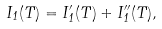Convert formula to latex. <formula><loc_0><loc_0><loc_500><loc_500>I _ { 1 } ( T ) = I ^ { \prime } _ { 1 } ( T ) + I ^ { \prime \prime } _ { 1 } ( T ) ,</formula> 